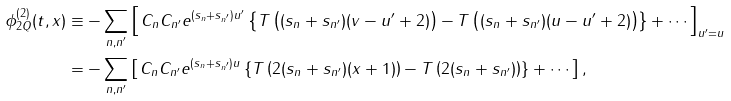<formula> <loc_0><loc_0><loc_500><loc_500>\phi ^ { ( 2 ) } _ { 2 Q } ( t , x ) & \equiv - \sum _ { n , n ^ { \prime } } \left [ \, C _ { n } C _ { n ^ { \prime } } e ^ { ( s _ { n } + s _ { n ^ { \prime } } ) u ^ { \prime } } \left \{ T \left ( ( s _ { n } + s _ { n ^ { \prime } } ) ( v - u ^ { \prime } + 2 ) \right ) - T \left ( ( s _ { n } + s _ { n ^ { \prime } } ) ( u - u ^ { \prime } + 2 ) \right ) \right \} + \cdots \, \right ] _ { u ^ { \prime } = u } \\ & = - \sum _ { n , n ^ { \prime } } \left [ \, C _ { n } C _ { n ^ { \prime } } e ^ { ( s _ { n } + s _ { n ^ { \prime } } ) u } \left \{ T \left ( 2 ( s _ { n } + s _ { n ^ { \prime } } ) ( x + 1 ) \right ) - T \left ( 2 ( s _ { n } + s _ { n ^ { \prime } } ) \right ) \right \} + \cdots \, \right ] ,</formula> 